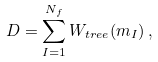<formula> <loc_0><loc_0><loc_500><loc_500>D = \sum _ { I = 1 } ^ { N _ { f } } W _ { t r e e } ( m _ { I } ) \, ,</formula> 